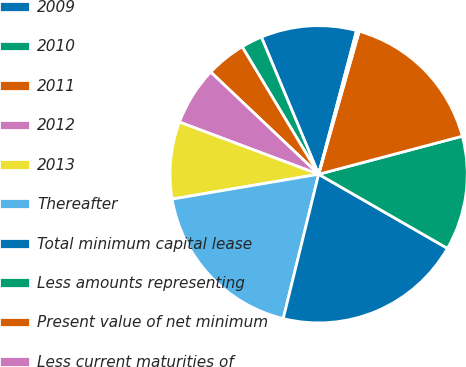Convert chart to OTSL. <chart><loc_0><loc_0><loc_500><loc_500><pie_chart><fcel>2009<fcel>2010<fcel>2011<fcel>2012<fcel>2013<fcel>Thereafter<fcel>Total minimum capital lease<fcel>Less amounts representing<fcel>Present value of net minimum<fcel>Less current maturities of<nl><fcel>10.4%<fcel>2.31%<fcel>4.33%<fcel>6.36%<fcel>8.38%<fcel>18.5%<fcel>20.52%<fcel>12.43%<fcel>16.48%<fcel>0.29%<nl></chart> 